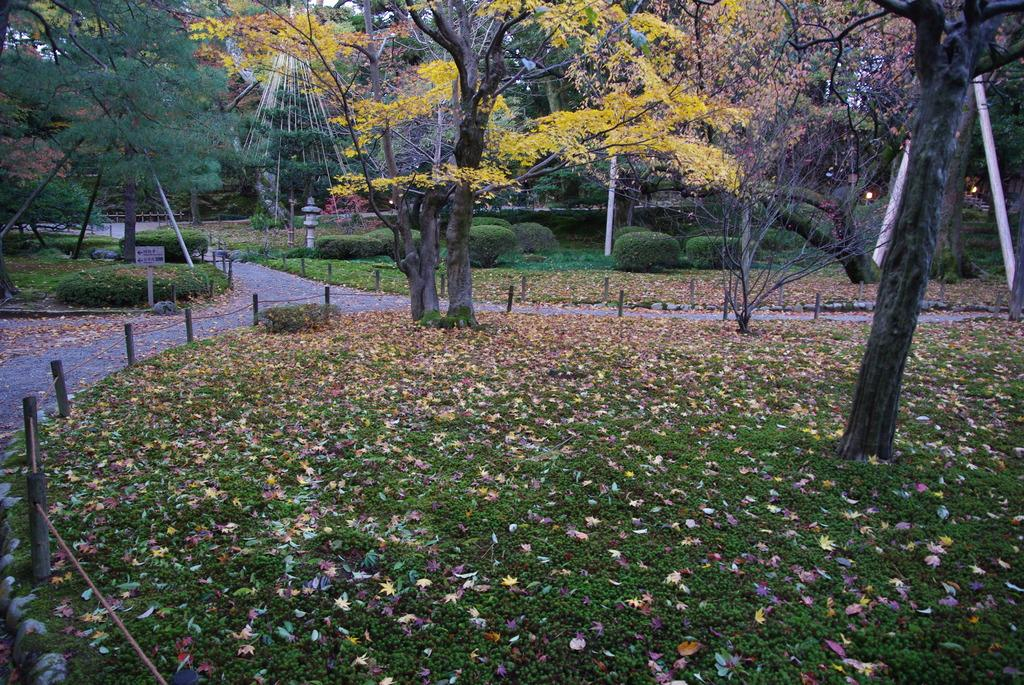What type of vegetation can be seen in the image? There are trees in the image. What is at the bottom of the image? There is grass at the bottom of the image. What type of structure is visible in the image? There are fences visible in the image. Where is the board located in the image? The board is on the left side of the image. How many chairs are visible in the image? There are no chairs present in the image. What angle is the board positioned at in the image? The angle of the board cannot be determined from the image, as it is not mentioned in the provided facts. 